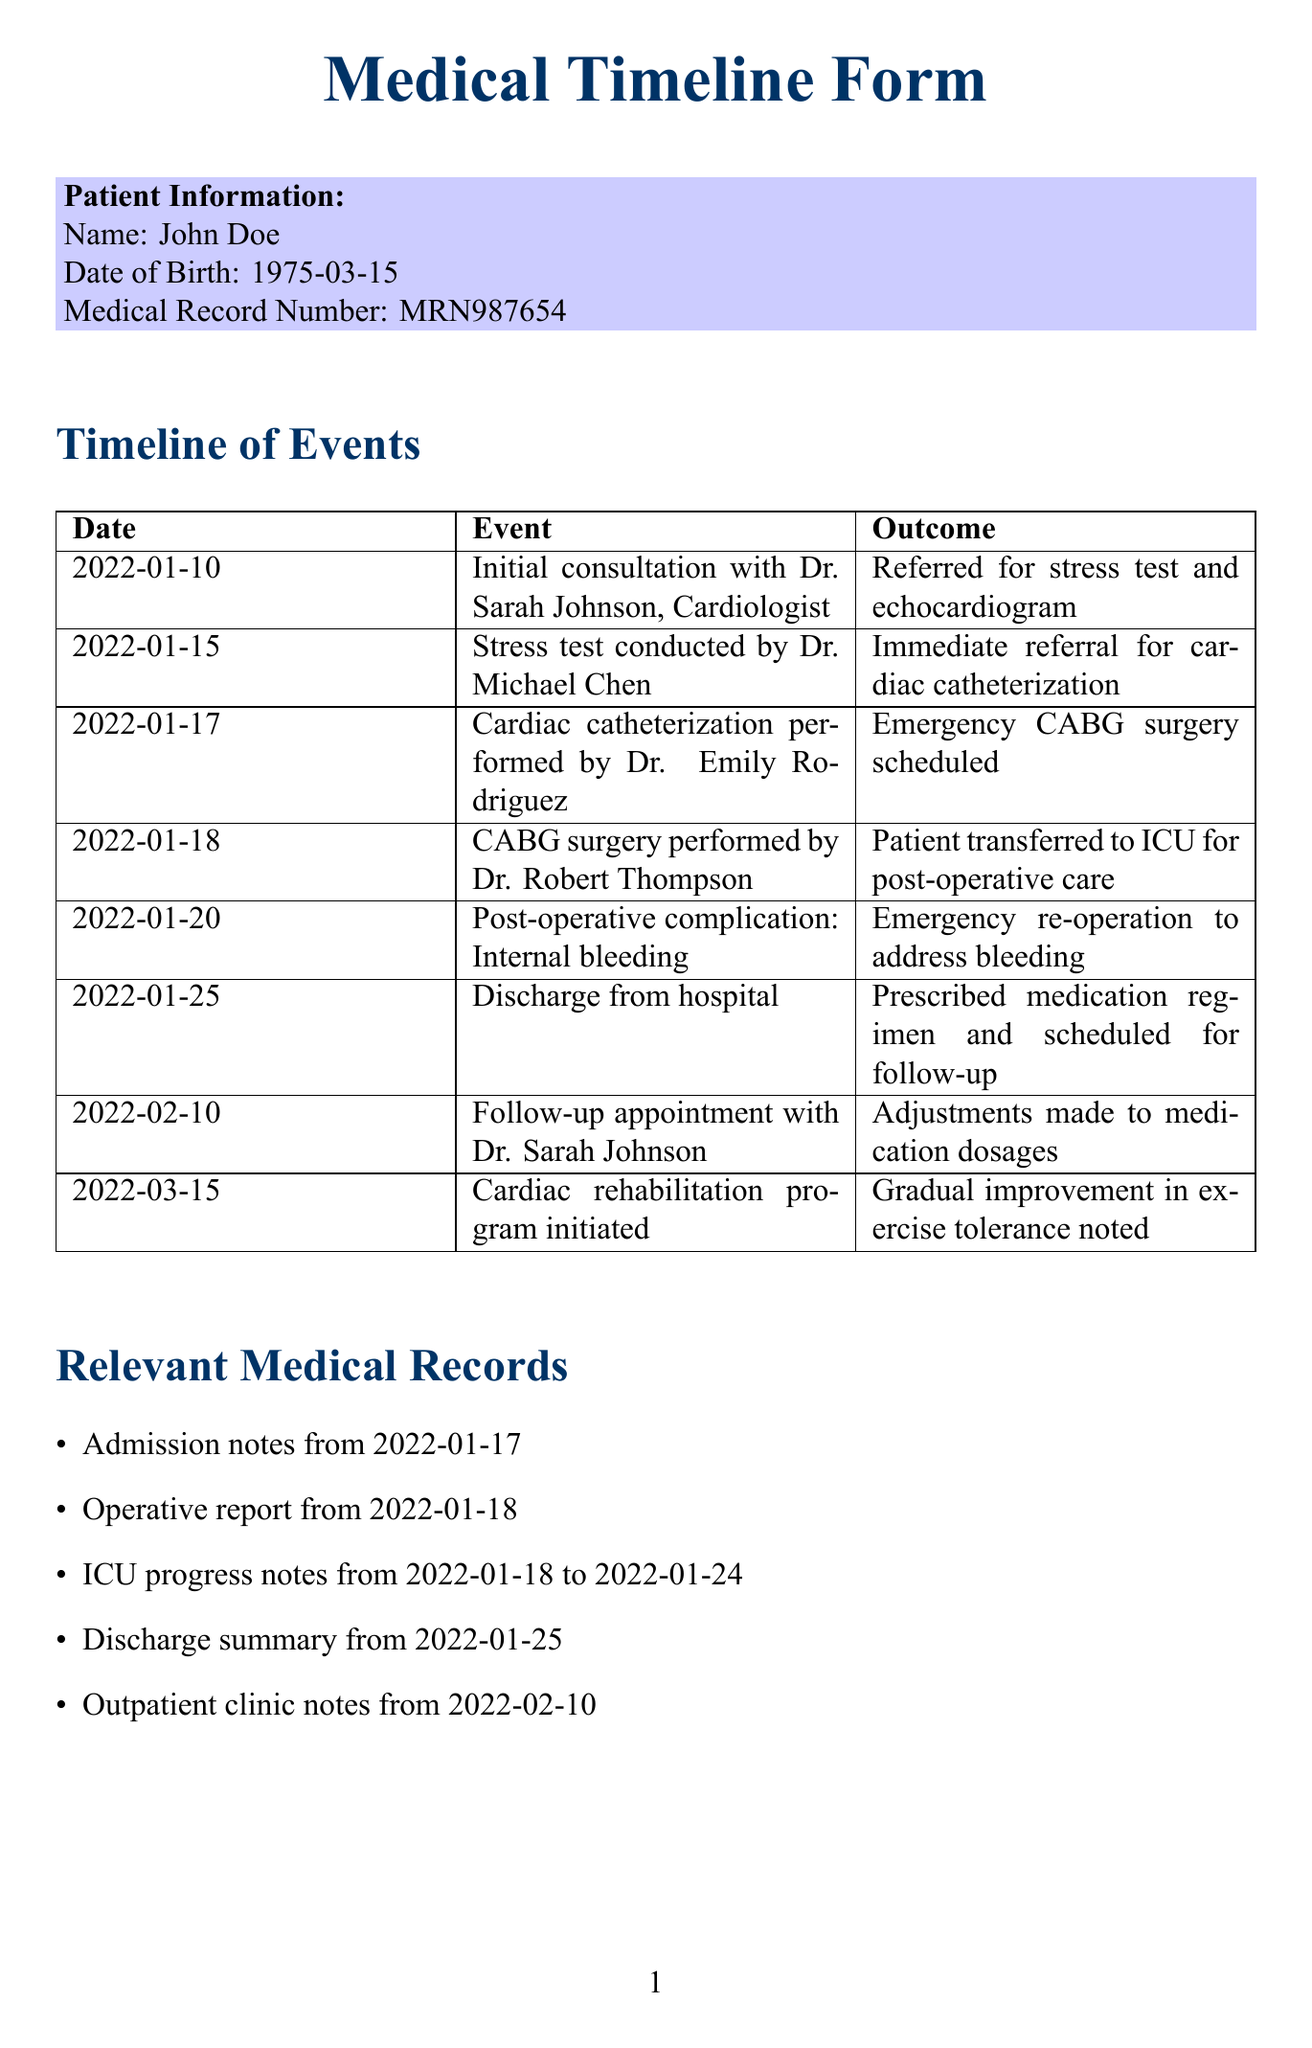What is the patient's name? The patient's name is provided in the patient information section of the document.
Answer: John Doe When was the CABG surgery performed? The date of the CABG surgery is listed in the timeline of events.
Answer: 2022-01-18 Who performed the cardiac catheterization? The name of the doctor who performed the cardiac catheterization is mentioned in the timeline.
Answer: Dr. Emily Rodriguez What complication occurred on January 20, 2022? The event details on this date describe a specific medical complication.
Answer: Internal bleeding What outcomes were noted after the cardiac rehabilitation program? The final entry in the timeline indicates the patient's improvement after the program.
Answer: Gradual improvement in exercise tolerance noted Which record is relevant from January 17, 2022? The relevant medical records section lists documents categorized by date.
Answer: Admission notes What is one potential negligence claim mentioned? The section on potential negligence claims outlines specific concerns regarding care.
Answer: Delay in diagnosing severity of coronary artery disease Who is the key witness that provided post-operative care? The key witnesses section identifies individuals involved in the patient's care.
Answer: Nurse Patricia Lee 